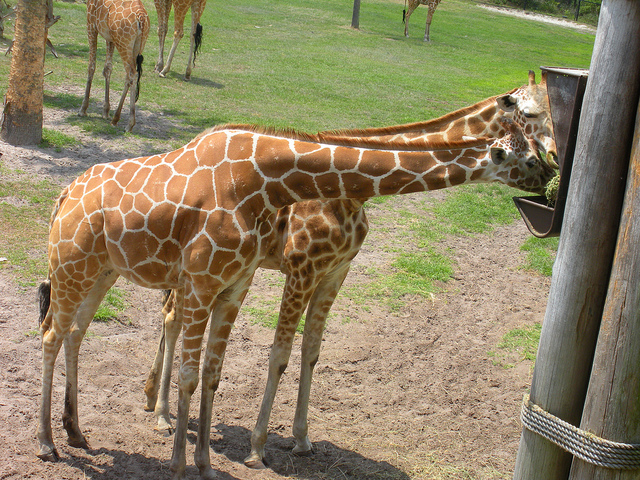<image>What is the relationship in the photo? I don't know for sure about the relationship between the individuals in the photo. They could be friends, family, or siblings. What is the relationship in the photo? I don't know the relationship in the photo. It could be fellow prisoners, siblings, friends, or brothers. 